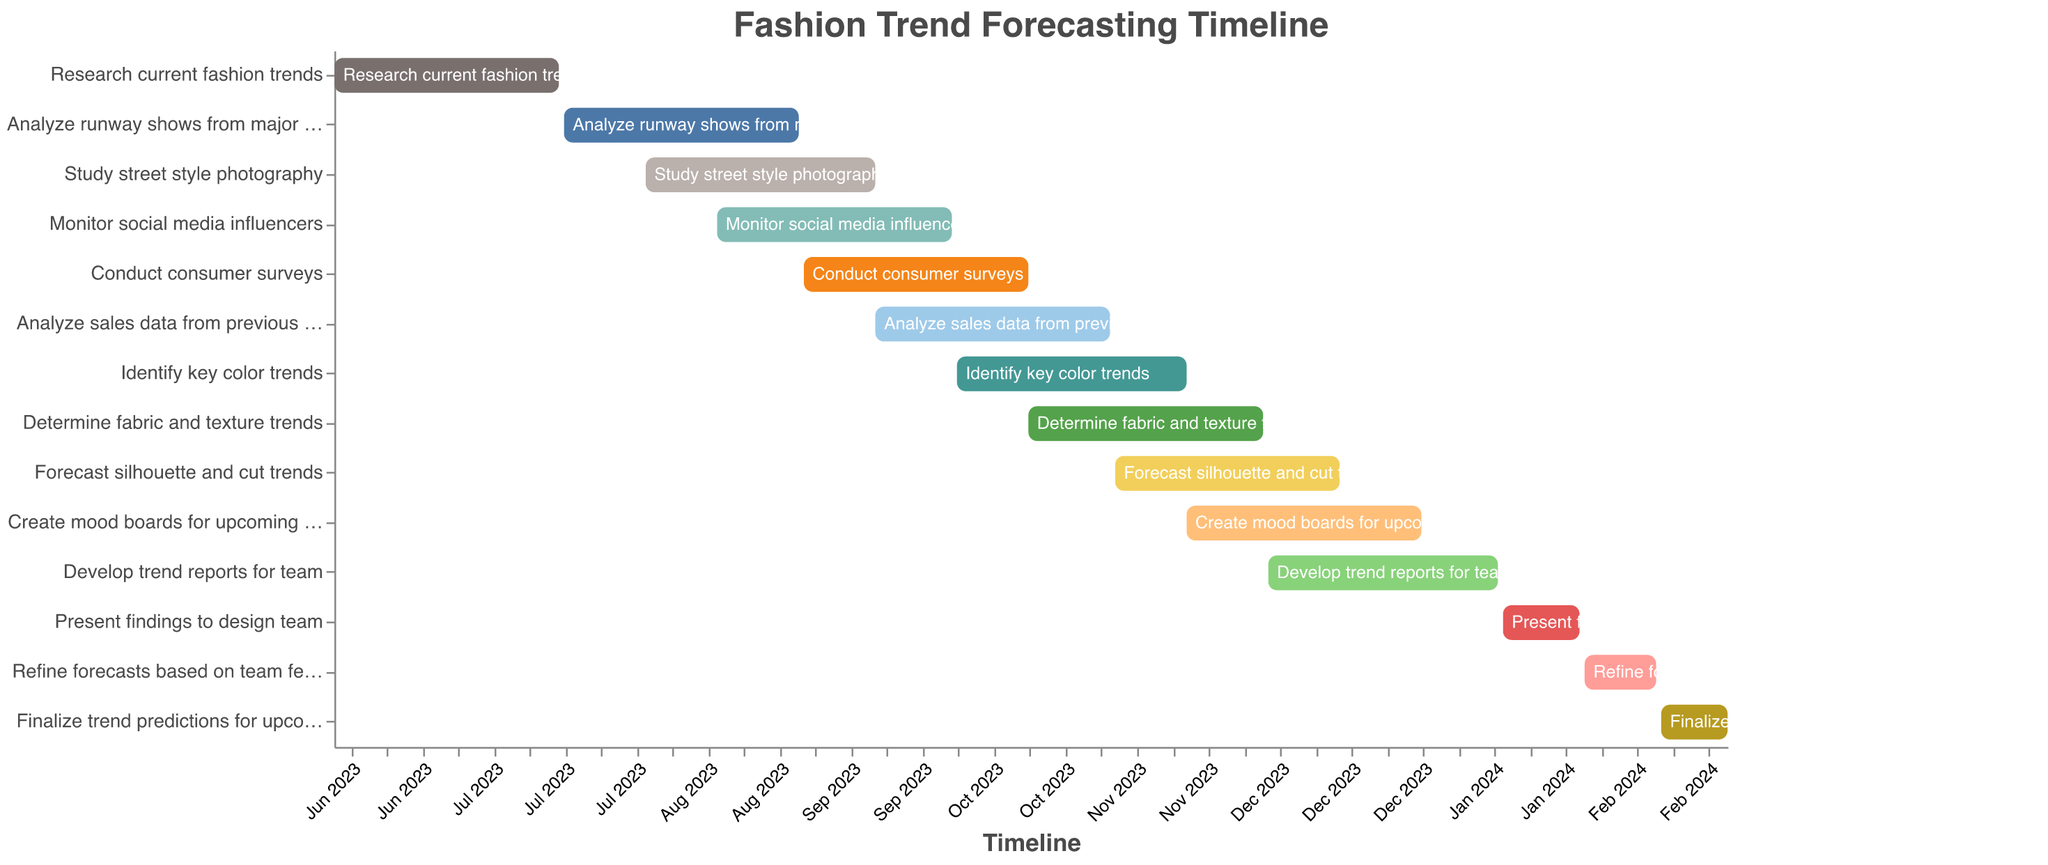What is the title of the chart? The title can be easily found at the top of the chart above the main visualization. It reads "Fashion Trend Forecasting Timeline".
Answer: Fashion Trend Forecasting Timeline During which period is the task "Create mood boards for upcoming seasons" scheduled? This task spans both a start date and an end date on the timeline. It begins on 2023-11-15 and ends on 2023-12-31.
Answer: November 15, 2023 to December 31, 2023 Which tasks are overlapping in September 2023? The chart has several tasks that are color-coded bars spanning across the timeline. During September 2023, "Study street style photography", "Monitor social media influencers", "Conduct consumer surveys", and "Analyze sales data from previous seasons" are overlapping.
Answer: Study street style photography, Monitor social media influencers, Conduct consumer surveys, Analyze sales data from previous seasons How long is the "Research current fashion trends" task? To determine the length, look at the start and end dates on the timeline. It starts on June 1, 2023, and ends on July 15, 2023, so counting both dates inclusively, it spans 45 days.
Answer: 45 days Which tasks extend into 2024? To identify tasks extending into 2024, look at the timeline bars that cross from 2023 into 2024. These are "Develop trend reports for team", "Present findings to design team", "Refine forecasts based on team feedback", and "Finalize trend predictions for upcoming seasons".
Answer: Develop trend reports for team, Present findings to design team, Refine forecasts based on team feedback, Finalize trend predictions for upcoming seasons What is the shortest task on the chart? By examining the length of the bars on the timeline, the task "Refine forecasts based on team feedback" spans from 2024-02-01 to 2024-02-15, so it is 15 days long, making it the shortest task.
Answer: Refine forecasts based on team feedback How many tasks commence in October 2023? The chart shows the start dates of each task. By observing the timeline, two tasks "Identify key color trends" and "Determine fabric and texture trends" start in October 2023.
Answer: 2 tasks Which task concludes first after the New Year 2024? Among the tasks continuing into 2024, the earliest to conclude by examining the timeline bars is "Develop trend reports for team", ending on January 15, 2024.
Answer: Develop trend reports for team 